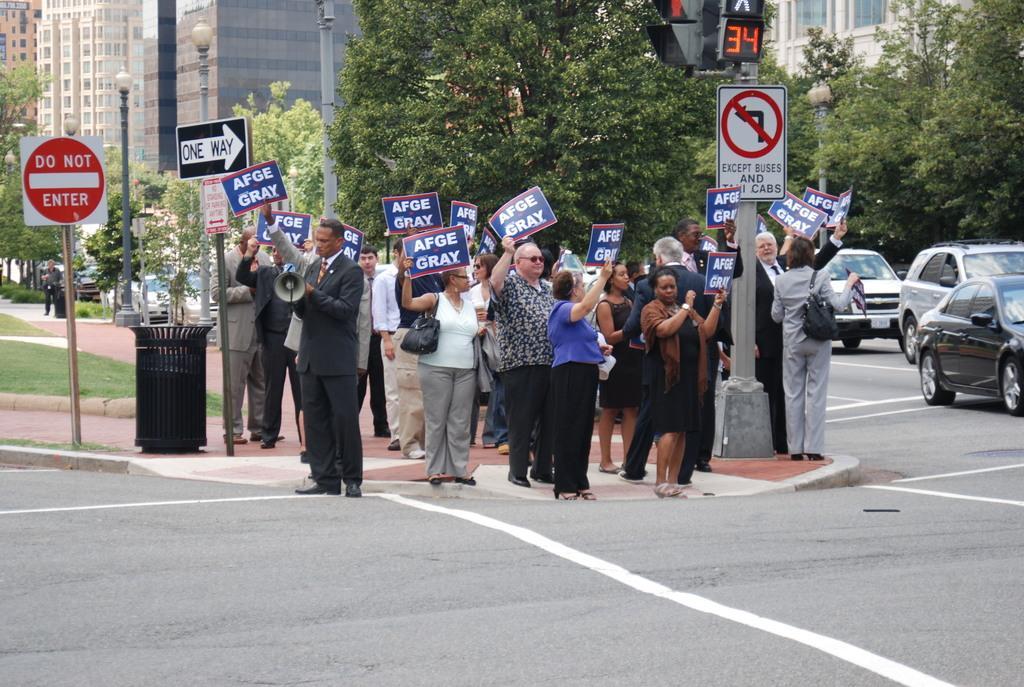Could you give a brief overview of what you see in this image? In the picture I can see this person wearing blazer is holding a microphone and standing on the road and in the background, we can see a few more people holding placards in their hands and standing on the sidewalk. Here we can see caution boards, trash can, traffic signal poles, vehicles moving on the road is on the right side of the image, we can see trees, light poles and the buildings in the background. 